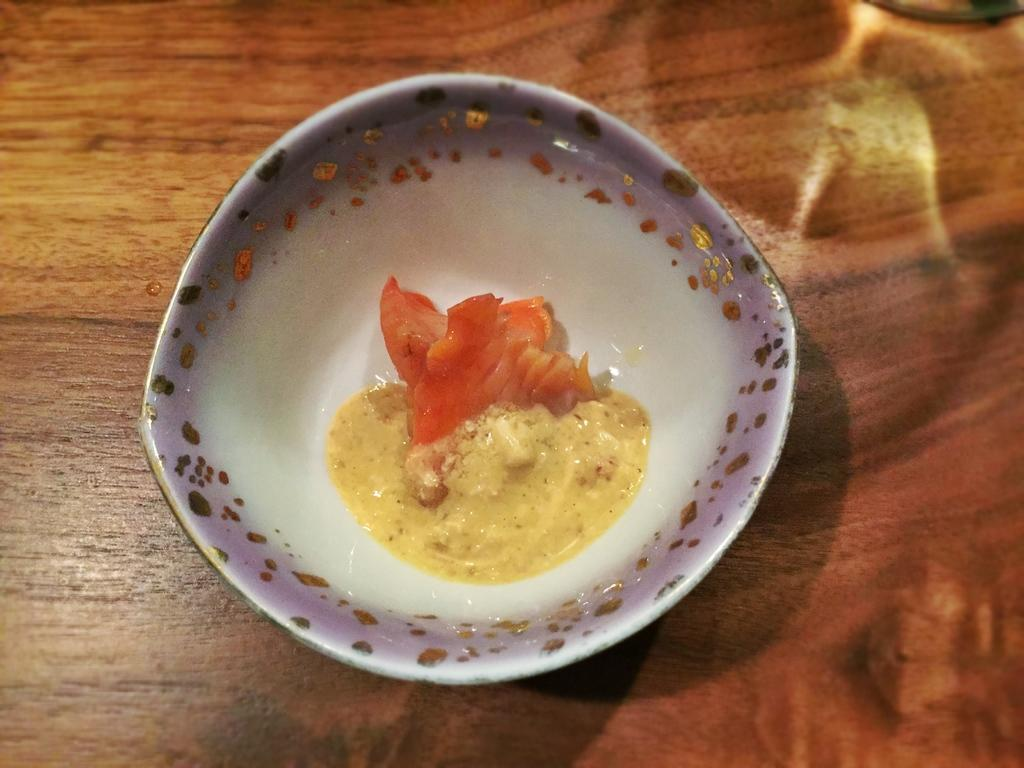What piece of furniture is present in the image? There is a table in the image. What is placed on the table? There is a bowl on the table. What is inside the bowl? There is food in the bowl. What type of flowers can be seen growing from the bowl in the image? There are no flowers present in the image; the bowl contains food. 